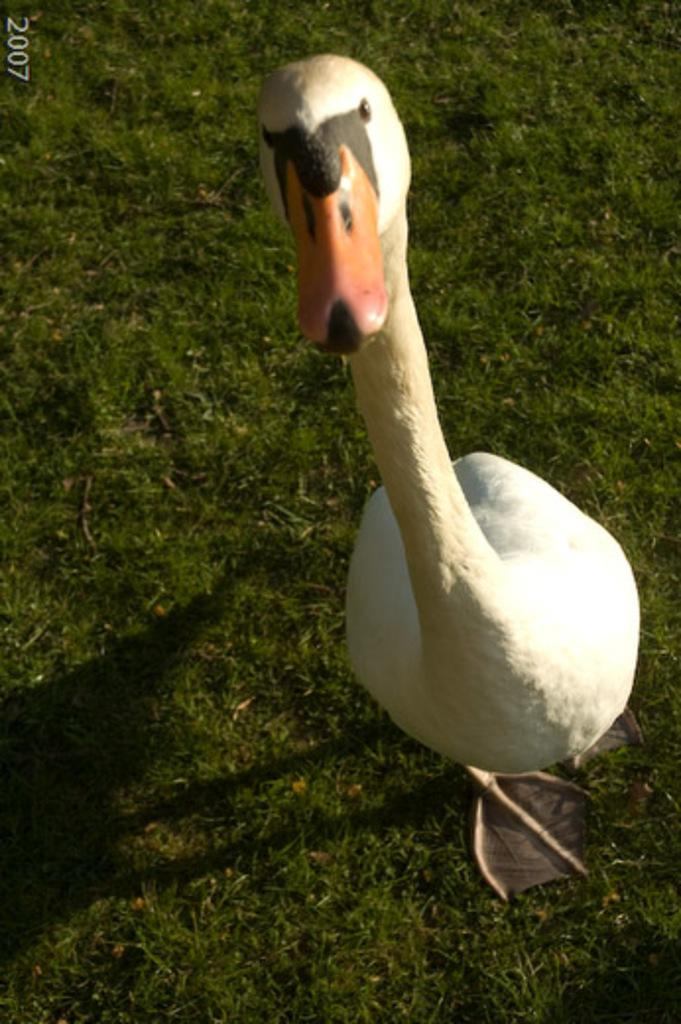What animal is present in the image? There is a duck in the image. Where is the duck located? The duck is on the ground. What else can be seen in the image besides the duck? There is text visible at the top of the image. What type of organization is the cow affiliated with in the image? There is no cow present in the image, so it is not possible to determine any affiliations. 